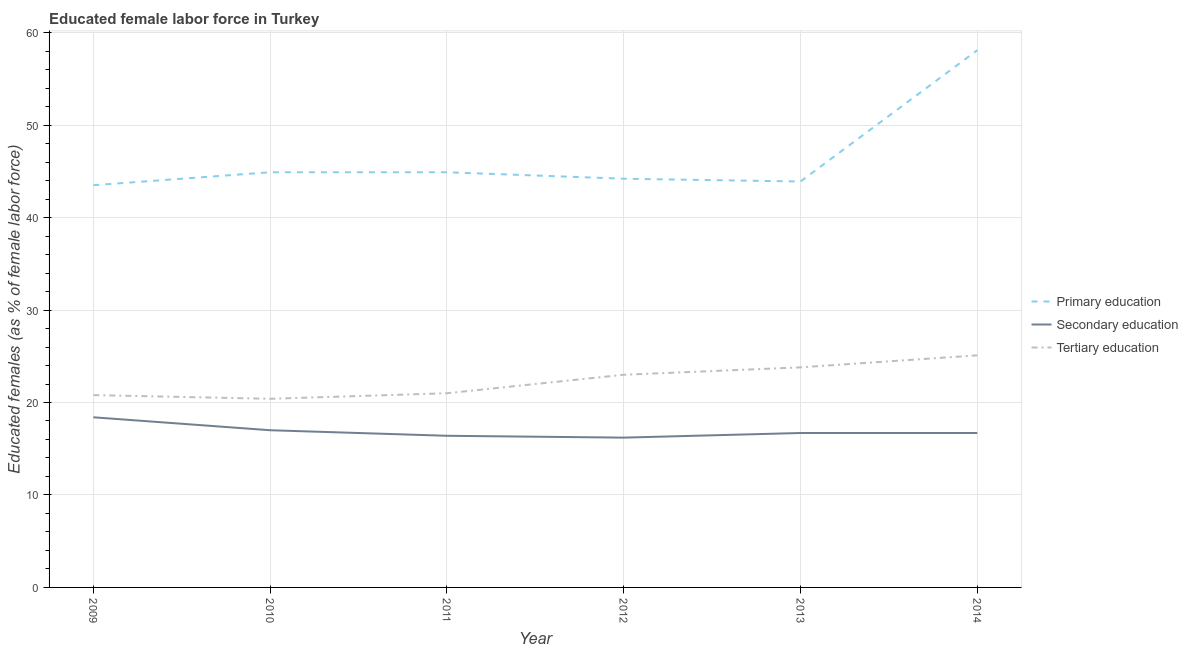Does the line corresponding to percentage of female labor force who received secondary education intersect with the line corresponding to percentage of female labor force who received primary education?
Make the answer very short. No. Is the number of lines equal to the number of legend labels?
Provide a short and direct response. Yes. What is the percentage of female labor force who received tertiary education in 2009?
Provide a short and direct response. 20.8. Across all years, what is the maximum percentage of female labor force who received secondary education?
Provide a short and direct response. 18.4. Across all years, what is the minimum percentage of female labor force who received secondary education?
Keep it short and to the point. 16.2. What is the total percentage of female labor force who received secondary education in the graph?
Give a very brief answer. 101.4. What is the difference between the percentage of female labor force who received secondary education in 2010 and that in 2013?
Offer a terse response. 0.3. What is the difference between the percentage of female labor force who received tertiary education in 2010 and the percentage of female labor force who received primary education in 2014?
Your response must be concise. -37.7. What is the average percentage of female labor force who received primary education per year?
Your answer should be very brief. 46.58. In the year 2009, what is the difference between the percentage of female labor force who received secondary education and percentage of female labor force who received primary education?
Make the answer very short. -25.1. What is the ratio of the percentage of female labor force who received primary education in 2009 to that in 2010?
Ensure brevity in your answer.  0.97. Is the difference between the percentage of female labor force who received tertiary education in 2010 and 2012 greater than the difference between the percentage of female labor force who received primary education in 2010 and 2012?
Offer a very short reply. No. What is the difference between the highest and the second highest percentage of female labor force who received primary education?
Keep it short and to the point. 13.2. What is the difference between the highest and the lowest percentage of female labor force who received tertiary education?
Provide a succinct answer. 4.7. Does the percentage of female labor force who received secondary education monotonically increase over the years?
Your answer should be compact. No. How many years are there in the graph?
Keep it short and to the point. 6. What is the difference between two consecutive major ticks on the Y-axis?
Your answer should be compact. 10. Does the graph contain grids?
Offer a very short reply. Yes. Where does the legend appear in the graph?
Make the answer very short. Center right. How are the legend labels stacked?
Your response must be concise. Vertical. What is the title of the graph?
Make the answer very short. Educated female labor force in Turkey. What is the label or title of the X-axis?
Provide a succinct answer. Year. What is the label or title of the Y-axis?
Your response must be concise. Educated females (as % of female labor force). What is the Educated females (as % of female labor force) of Primary education in 2009?
Keep it short and to the point. 43.5. What is the Educated females (as % of female labor force) of Secondary education in 2009?
Make the answer very short. 18.4. What is the Educated females (as % of female labor force) of Tertiary education in 2009?
Provide a succinct answer. 20.8. What is the Educated females (as % of female labor force) of Primary education in 2010?
Provide a succinct answer. 44.9. What is the Educated females (as % of female labor force) of Secondary education in 2010?
Keep it short and to the point. 17. What is the Educated females (as % of female labor force) in Tertiary education in 2010?
Make the answer very short. 20.4. What is the Educated females (as % of female labor force) in Primary education in 2011?
Keep it short and to the point. 44.9. What is the Educated females (as % of female labor force) of Secondary education in 2011?
Provide a succinct answer. 16.4. What is the Educated females (as % of female labor force) in Primary education in 2012?
Offer a terse response. 44.2. What is the Educated females (as % of female labor force) in Secondary education in 2012?
Your answer should be very brief. 16.2. What is the Educated females (as % of female labor force) in Primary education in 2013?
Your answer should be compact. 43.9. What is the Educated females (as % of female labor force) in Secondary education in 2013?
Give a very brief answer. 16.7. What is the Educated females (as % of female labor force) of Tertiary education in 2013?
Offer a very short reply. 23.8. What is the Educated females (as % of female labor force) of Primary education in 2014?
Provide a succinct answer. 58.1. What is the Educated females (as % of female labor force) of Secondary education in 2014?
Keep it short and to the point. 16.7. What is the Educated females (as % of female labor force) in Tertiary education in 2014?
Your answer should be very brief. 25.1. Across all years, what is the maximum Educated females (as % of female labor force) in Primary education?
Make the answer very short. 58.1. Across all years, what is the maximum Educated females (as % of female labor force) of Secondary education?
Your answer should be compact. 18.4. Across all years, what is the maximum Educated females (as % of female labor force) of Tertiary education?
Give a very brief answer. 25.1. Across all years, what is the minimum Educated females (as % of female labor force) of Primary education?
Make the answer very short. 43.5. Across all years, what is the minimum Educated females (as % of female labor force) in Secondary education?
Ensure brevity in your answer.  16.2. Across all years, what is the minimum Educated females (as % of female labor force) of Tertiary education?
Make the answer very short. 20.4. What is the total Educated females (as % of female labor force) of Primary education in the graph?
Ensure brevity in your answer.  279.5. What is the total Educated females (as % of female labor force) of Secondary education in the graph?
Keep it short and to the point. 101.4. What is the total Educated females (as % of female labor force) of Tertiary education in the graph?
Give a very brief answer. 134.1. What is the difference between the Educated females (as % of female labor force) in Tertiary education in 2009 and that in 2010?
Your response must be concise. 0.4. What is the difference between the Educated females (as % of female labor force) in Tertiary education in 2009 and that in 2011?
Your response must be concise. -0.2. What is the difference between the Educated females (as % of female labor force) of Primary education in 2009 and that in 2012?
Your response must be concise. -0.7. What is the difference between the Educated females (as % of female labor force) of Secondary education in 2009 and that in 2012?
Make the answer very short. 2.2. What is the difference between the Educated females (as % of female labor force) in Primary education in 2009 and that in 2013?
Provide a short and direct response. -0.4. What is the difference between the Educated females (as % of female labor force) of Tertiary education in 2009 and that in 2013?
Make the answer very short. -3. What is the difference between the Educated females (as % of female labor force) in Primary education in 2009 and that in 2014?
Make the answer very short. -14.6. What is the difference between the Educated females (as % of female labor force) in Primary education in 2010 and that in 2011?
Your response must be concise. 0. What is the difference between the Educated females (as % of female labor force) of Secondary education in 2010 and that in 2011?
Keep it short and to the point. 0.6. What is the difference between the Educated females (as % of female labor force) in Tertiary education in 2010 and that in 2013?
Offer a very short reply. -3.4. What is the difference between the Educated females (as % of female labor force) of Primary education in 2010 and that in 2014?
Ensure brevity in your answer.  -13.2. What is the difference between the Educated females (as % of female labor force) of Tertiary education in 2010 and that in 2014?
Ensure brevity in your answer.  -4.7. What is the difference between the Educated females (as % of female labor force) of Secondary education in 2011 and that in 2012?
Your answer should be compact. 0.2. What is the difference between the Educated females (as % of female labor force) in Primary education in 2011 and that in 2013?
Your answer should be very brief. 1. What is the difference between the Educated females (as % of female labor force) of Secondary education in 2011 and that in 2013?
Make the answer very short. -0.3. What is the difference between the Educated females (as % of female labor force) of Tertiary education in 2011 and that in 2014?
Keep it short and to the point. -4.1. What is the difference between the Educated females (as % of female labor force) of Secondary education in 2012 and that in 2013?
Ensure brevity in your answer.  -0.5. What is the difference between the Educated females (as % of female labor force) of Tertiary education in 2012 and that in 2013?
Make the answer very short. -0.8. What is the difference between the Educated females (as % of female labor force) in Secondary education in 2012 and that in 2014?
Offer a very short reply. -0.5. What is the difference between the Educated females (as % of female labor force) in Tertiary education in 2012 and that in 2014?
Your answer should be compact. -2.1. What is the difference between the Educated females (as % of female labor force) of Tertiary education in 2013 and that in 2014?
Your response must be concise. -1.3. What is the difference between the Educated females (as % of female labor force) in Primary education in 2009 and the Educated females (as % of female labor force) in Secondary education in 2010?
Ensure brevity in your answer.  26.5. What is the difference between the Educated females (as % of female labor force) in Primary education in 2009 and the Educated females (as % of female labor force) in Tertiary education in 2010?
Provide a short and direct response. 23.1. What is the difference between the Educated females (as % of female labor force) in Secondary education in 2009 and the Educated females (as % of female labor force) in Tertiary education in 2010?
Offer a very short reply. -2. What is the difference between the Educated females (as % of female labor force) in Primary education in 2009 and the Educated females (as % of female labor force) in Secondary education in 2011?
Provide a short and direct response. 27.1. What is the difference between the Educated females (as % of female labor force) in Primary education in 2009 and the Educated females (as % of female labor force) in Secondary education in 2012?
Your response must be concise. 27.3. What is the difference between the Educated females (as % of female labor force) of Secondary education in 2009 and the Educated females (as % of female labor force) of Tertiary education in 2012?
Make the answer very short. -4.6. What is the difference between the Educated females (as % of female labor force) in Primary education in 2009 and the Educated females (as % of female labor force) in Secondary education in 2013?
Provide a short and direct response. 26.8. What is the difference between the Educated females (as % of female labor force) in Primary education in 2009 and the Educated females (as % of female labor force) in Tertiary education in 2013?
Offer a very short reply. 19.7. What is the difference between the Educated females (as % of female labor force) in Secondary education in 2009 and the Educated females (as % of female labor force) in Tertiary education in 2013?
Offer a terse response. -5.4. What is the difference between the Educated females (as % of female labor force) of Primary education in 2009 and the Educated females (as % of female labor force) of Secondary education in 2014?
Ensure brevity in your answer.  26.8. What is the difference between the Educated females (as % of female labor force) of Primary education in 2009 and the Educated females (as % of female labor force) of Tertiary education in 2014?
Your answer should be compact. 18.4. What is the difference between the Educated females (as % of female labor force) of Secondary education in 2009 and the Educated females (as % of female labor force) of Tertiary education in 2014?
Give a very brief answer. -6.7. What is the difference between the Educated females (as % of female labor force) of Primary education in 2010 and the Educated females (as % of female labor force) of Tertiary education in 2011?
Your response must be concise. 23.9. What is the difference between the Educated females (as % of female labor force) in Primary education in 2010 and the Educated females (as % of female labor force) in Secondary education in 2012?
Ensure brevity in your answer.  28.7. What is the difference between the Educated females (as % of female labor force) in Primary education in 2010 and the Educated females (as % of female labor force) in Tertiary education in 2012?
Your answer should be very brief. 21.9. What is the difference between the Educated females (as % of female labor force) of Secondary education in 2010 and the Educated females (as % of female labor force) of Tertiary education in 2012?
Keep it short and to the point. -6. What is the difference between the Educated females (as % of female labor force) in Primary education in 2010 and the Educated females (as % of female labor force) in Secondary education in 2013?
Your answer should be compact. 28.2. What is the difference between the Educated females (as % of female labor force) of Primary education in 2010 and the Educated females (as % of female labor force) of Tertiary education in 2013?
Ensure brevity in your answer.  21.1. What is the difference between the Educated females (as % of female labor force) in Primary education in 2010 and the Educated females (as % of female labor force) in Secondary education in 2014?
Your answer should be compact. 28.2. What is the difference between the Educated females (as % of female labor force) in Primary education in 2010 and the Educated females (as % of female labor force) in Tertiary education in 2014?
Provide a short and direct response. 19.8. What is the difference between the Educated females (as % of female labor force) in Secondary education in 2010 and the Educated females (as % of female labor force) in Tertiary education in 2014?
Provide a short and direct response. -8.1. What is the difference between the Educated females (as % of female labor force) in Primary education in 2011 and the Educated females (as % of female labor force) in Secondary education in 2012?
Your response must be concise. 28.7. What is the difference between the Educated females (as % of female labor force) of Primary education in 2011 and the Educated females (as % of female labor force) of Tertiary education in 2012?
Your response must be concise. 21.9. What is the difference between the Educated females (as % of female labor force) of Primary education in 2011 and the Educated females (as % of female labor force) of Secondary education in 2013?
Give a very brief answer. 28.2. What is the difference between the Educated females (as % of female labor force) of Primary education in 2011 and the Educated females (as % of female labor force) of Tertiary education in 2013?
Your response must be concise. 21.1. What is the difference between the Educated females (as % of female labor force) of Secondary education in 2011 and the Educated females (as % of female labor force) of Tertiary education in 2013?
Offer a very short reply. -7.4. What is the difference between the Educated females (as % of female labor force) in Primary education in 2011 and the Educated females (as % of female labor force) in Secondary education in 2014?
Provide a short and direct response. 28.2. What is the difference between the Educated females (as % of female labor force) of Primary education in 2011 and the Educated females (as % of female labor force) of Tertiary education in 2014?
Provide a short and direct response. 19.8. What is the difference between the Educated females (as % of female labor force) in Primary education in 2012 and the Educated females (as % of female labor force) in Secondary education in 2013?
Your answer should be compact. 27.5. What is the difference between the Educated females (as % of female labor force) of Primary education in 2012 and the Educated females (as % of female labor force) of Tertiary education in 2013?
Ensure brevity in your answer.  20.4. What is the difference between the Educated females (as % of female labor force) in Primary education in 2012 and the Educated females (as % of female labor force) in Secondary education in 2014?
Ensure brevity in your answer.  27.5. What is the difference between the Educated females (as % of female labor force) in Primary education in 2013 and the Educated females (as % of female labor force) in Secondary education in 2014?
Provide a short and direct response. 27.2. What is the difference between the Educated females (as % of female labor force) in Primary education in 2013 and the Educated females (as % of female labor force) in Tertiary education in 2014?
Offer a terse response. 18.8. What is the average Educated females (as % of female labor force) in Primary education per year?
Your response must be concise. 46.58. What is the average Educated females (as % of female labor force) of Tertiary education per year?
Provide a short and direct response. 22.35. In the year 2009, what is the difference between the Educated females (as % of female labor force) in Primary education and Educated females (as % of female labor force) in Secondary education?
Your response must be concise. 25.1. In the year 2009, what is the difference between the Educated females (as % of female labor force) in Primary education and Educated females (as % of female labor force) in Tertiary education?
Offer a very short reply. 22.7. In the year 2010, what is the difference between the Educated females (as % of female labor force) of Primary education and Educated females (as % of female labor force) of Secondary education?
Your response must be concise. 27.9. In the year 2010, what is the difference between the Educated females (as % of female labor force) of Primary education and Educated females (as % of female labor force) of Tertiary education?
Provide a short and direct response. 24.5. In the year 2010, what is the difference between the Educated females (as % of female labor force) in Secondary education and Educated females (as % of female labor force) in Tertiary education?
Provide a short and direct response. -3.4. In the year 2011, what is the difference between the Educated females (as % of female labor force) in Primary education and Educated females (as % of female labor force) in Tertiary education?
Your response must be concise. 23.9. In the year 2011, what is the difference between the Educated females (as % of female labor force) of Secondary education and Educated females (as % of female labor force) of Tertiary education?
Ensure brevity in your answer.  -4.6. In the year 2012, what is the difference between the Educated females (as % of female labor force) of Primary education and Educated females (as % of female labor force) of Secondary education?
Your response must be concise. 28. In the year 2012, what is the difference between the Educated females (as % of female labor force) in Primary education and Educated females (as % of female labor force) in Tertiary education?
Keep it short and to the point. 21.2. In the year 2012, what is the difference between the Educated females (as % of female labor force) in Secondary education and Educated females (as % of female labor force) in Tertiary education?
Provide a succinct answer. -6.8. In the year 2013, what is the difference between the Educated females (as % of female labor force) of Primary education and Educated females (as % of female labor force) of Secondary education?
Provide a succinct answer. 27.2. In the year 2013, what is the difference between the Educated females (as % of female labor force) in Primary education and Educated females (as % of female labor force) in Tertiary education?
Make the answer very short. 20.1. In the year 2014, what is the difference between the Educated females (as % of female labor force) of Primary education and Educated females (as % of female labor force) of Secondary education?
Offer a terse response. 41.4. In the year 2014, what is the difference between the Educated females (as % of female labor force) of Primary education and Educated females (as % of female labor force) of Tertiary education?
Keep it short and to the point. 33. In the year 2014, what is the difference between the Educated females (as % of female labor force) of Secondary education and Educated females (as % of female labor force) of Tertiary education?
Provide a short and direct response. -8.4. What is the ratio of the Educated females (as % of female labor force) of Primary education in 2009 to that in 2010?
Give a very brief answer. 0.97. What is the ratio of the Educated females (as % of female labor force) in Secondary education in 2009 to that in 2010?
Give a very brief answer. 1.08. What is the ratio of the Educated females (as % of female labor force) in Tertiary education in 2009 to that in 2010?
Your answer should be very brief. 1.02. What is the ratio of the Educated females (as % of female labor force) in Primary education in 2009 to that in 2011?
Ensure brevity in your answer.  0.97. What is the ratio of the Educated females (as % of female labor force) in Secondary education in 2009 to that in 2011?
Your answer should be very brief. 1.12. What is the ratio of the Educated females (as % of female labor force) in Primary education in 2009 to that in 2012?
Your response must be concise. 0.98. What is the ratio of the Educated females (as % of female labor force) in Secondary education in 2009 to that in 2012?
Give a very brief answer. 1.14. What is the ratio of the Educated females (as % of female labor force) in Tertiary education in 2009 to that in 2012?
Make the answer very short. 0.9. What is the ratio of the Educated females (as % of female labor force) in Primary education in 2009 to that in 2013?
Ensure brevity in your answer.  0.99. What is the ratio of the Educated females (as % of female labor force) of Secondary education in 2009 to that in 2013?
Provide a short and direct response. 1.1. What is the ratio of the Educated females (as % of female labor force) of Tertiary education in 2009 to that in 2013?
Your response must be concise. 0.87. What is the ratio of the Educated females (as % of female labor force) in Primary education in 2009 to that in 2014?
Your answer should be compact. 0.75. What is the ratio of the Educated females (as % of female labor force) in Secondary education in 2009 to that in 2014?
Provide a short and direct response. 1.1. What is the ratio of the Educated females (as % of female labor force) in Tertiary education in 2009 to that in 2014?
Provide a succinct answer. 0.83. What is the ratio of the Educated females (as % of female labor force) in Secondary education in 2010 to that in 2011?
Provide a succinct answer. 1.04. What is the ratio of the Educated females (as % of female labor force) in Tertiary education in 2010 to that in 2011?
Offer a very short reply. 0.97. What is the ratio of the Educated females (as % of female labor force) in Primary education in 2010 to that in 2012?
Offer a very short reply. 1.02. What is the ratio of the Educated females (as % of female labor force) of Secondary education in 2010 to that in 2012?
Your answer should be compact. 1.05. What is the ratio of the Educated females (as % of female labor force) in Tertiary education in 2010 to that in 2012?
Keep it short and to the point. 0.89. What is the ratio of the Educated females (as % of female labor force) in Primary education in 2010 to that in 2013?
Offer a very short reply. 1.02. What is the ratio of the Educated females (as % of female labor force) in Primary education in 2010 to that in 2014?
Offer a terse response. 0.77. What is the ratio of the Educated females (as % of female labor force) of Tertiary education in 2010 to that in 2014?
Your response must be concise. 0.81. What is the ratio of the Educated females (as % of female labor force) of Primary education in 2011 to that in 2012?
Keep it short and to the point. 1.02. What is the ratio of the Educated females (as % of female labor force) in Secondary education in 2011 to that in 2012?
Provide a succinct answer. 1.01. What is the ratio of the Educated females (as % of female labor force) of Tertiary education in 2011 to that in 2012?
Keep it short and to the point. 0.91. What is the ratio of the Educated females (as % of female labor force) in Primary education in 2011 to that in 2013?
Offer a very short reply. 1.02. What is the ratio of the Educated females (as % of female labor force) in Secondary education in 2011 to that in 2013?
Make the answer very short. 0.98. What is the ratio of the Educated females (as % of female labor force) of Tertiary education in 2011 to that in 2013?
Your answer should be very brief. 0.88. What is the ratio of the Educated females (as % of female labor force) of Primary education in 2011 to that in 2014?
Your answer should be compact. 0.77. What is the ratio of the Educated females (as % of female labor force) of Secondary education in 2011 to that in 2014?
Make the answer very short. 0.98. What is the ratio of the Educated females (as % of female labor force) in Tertiary education in 2011 to that in 2014?
Keep it short and to the point. 0.84. What is the ratio of the Educated females (as % of female labor force) in Primary education in 2012 to that in 2013?
Your answer should be compact. 1.01. What is the ratio of the Educated females (as % of female labor force) of Secondary education in 2012 to that in 2013?
Offer a very short reply. 0.97. What is the ratio of the Educated females (as % of female labor force) of Tertiary education in 2012 to that in 2013?
Your response must be concise. 0.97. What is the ratio of the Educated females (as % of female labor force) of Primary education in 2012 to that in 2014?
Offer a very short reply. 0.76. What is the ratio of the Educated females (as % of female labor force) in Secondary education in 2012 to that in 2014?
Your response must be concise. 0.97. What is the ratio of the Educated females (as % of female labor force) of Tertiary education in 2012 to that in 2014?
Your response must be concise. 0.92. What is the ratio of the Educated females (as % of female labor force) of Primary education in 2013 to that in 2014?
Ensure brevity in your answer.  0.76. What is the ratio of the Educated females (as % of female labor force) in Tertiary education in 2013 to that in 2014?
Make the answer very short. 0.95. What is the difference between the highest and the second highest Educated females (as % of female labor force) in Primary education?
Keep it short and to the point. 13.2. What is the difference between the highest and the second highest Educated females (as % of female labor force) of Tertiary education?
Ensure brevity in your answer.  1.3. What is the difference between the highest and the lowest Educated females (as % of female labor force) of Secondary education?
Your response must be concise. 2.2. 